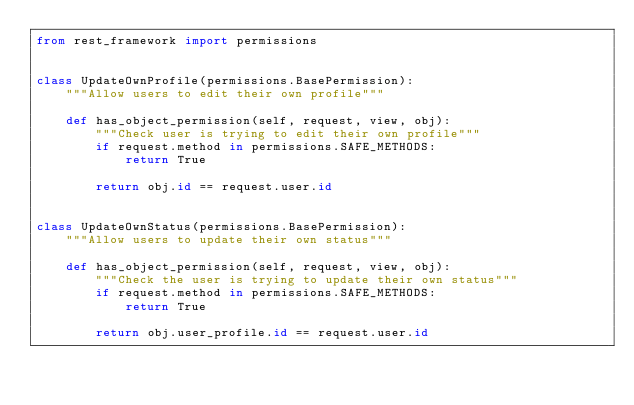Convert code to text. <code><loc_0><loc_0><loc_500><loc_500><_Python_>from rest_framework import permissions


class UpdateOwnProfile(permissions.BasePermission):
    """Allow users to edit their own profile"""

    def has_object_permission(self, request, view, obj):
        """Check user is trying to edit their own profile"""
        if request.method in permissions.SAFE_METHODS:
            return True

        return obj.id == request.user.id


class UpdateOwnStatus(permissions.BasePermission):
    """Allow users to update their own status"""

    def has_object_permission(self, request, view, obj):
        """Check the user is trying to update their own status"""
        if request.method in permissions.SAFE_METHODS:
            return True

        return obj.user_profile.id == request.user.id

        
</code> 